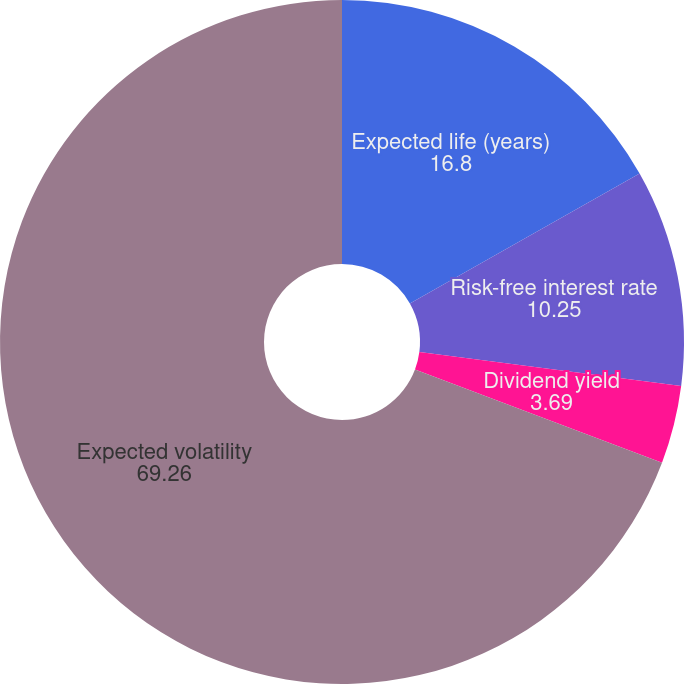<chart> <loc_0><loc_0><loc_500><loc_500><pie_chart><fcel>Expected life (years)<fcel>Risk-free interest rate<fcel>Dividend yield<fcel>Expected volatility<nl><fcel>16.8%<fcel>10.25%<fcel>3.69%<fcel>69.26%<nl></chart> 